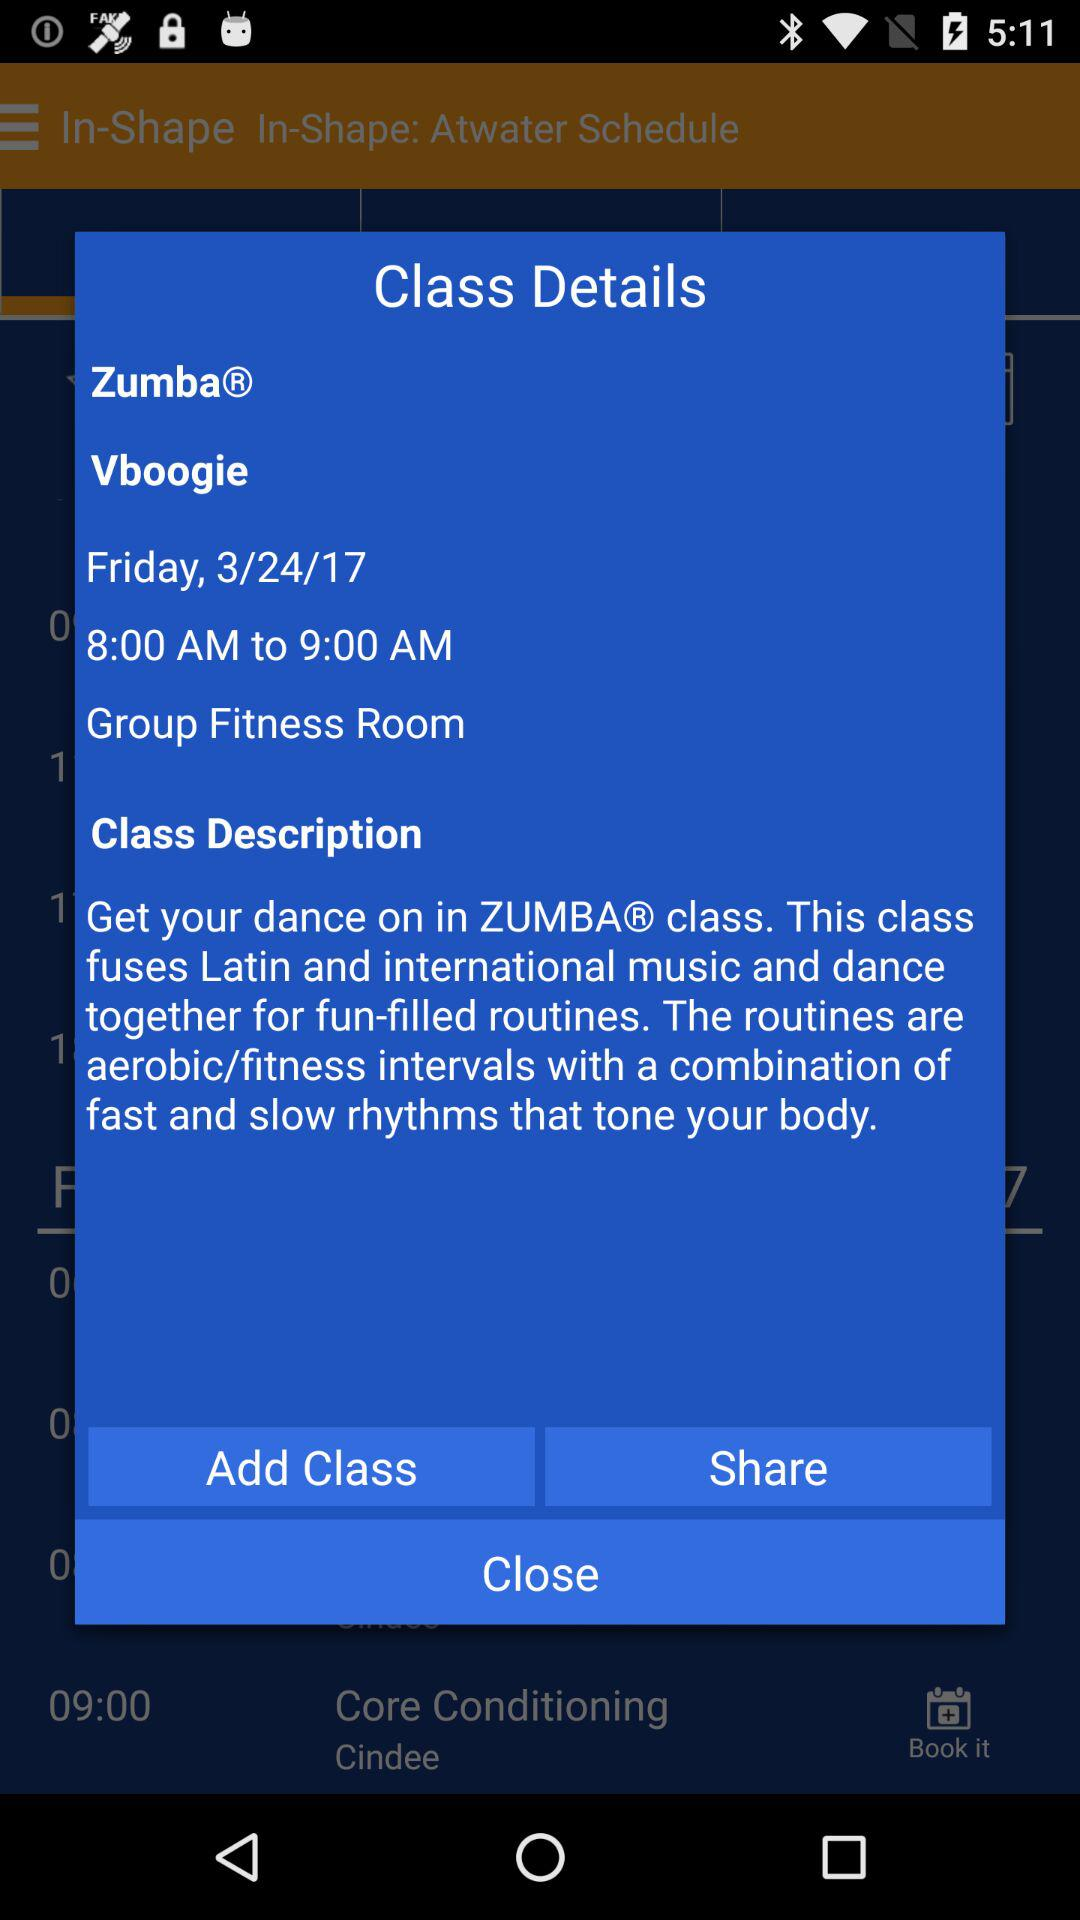What is the time? The time is 8:00 AM to 9:00 AM. 